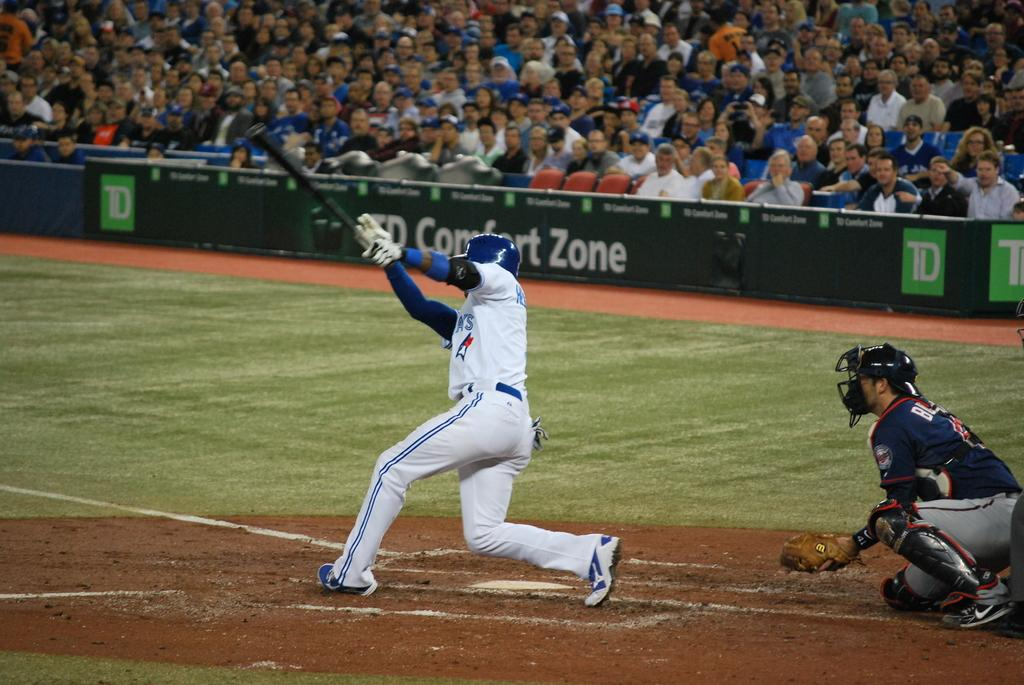<image>
Write a terse but informative summary of the picture. A baseball player is swinging a bat with a sign reading "Comfort Zone" in the background. 